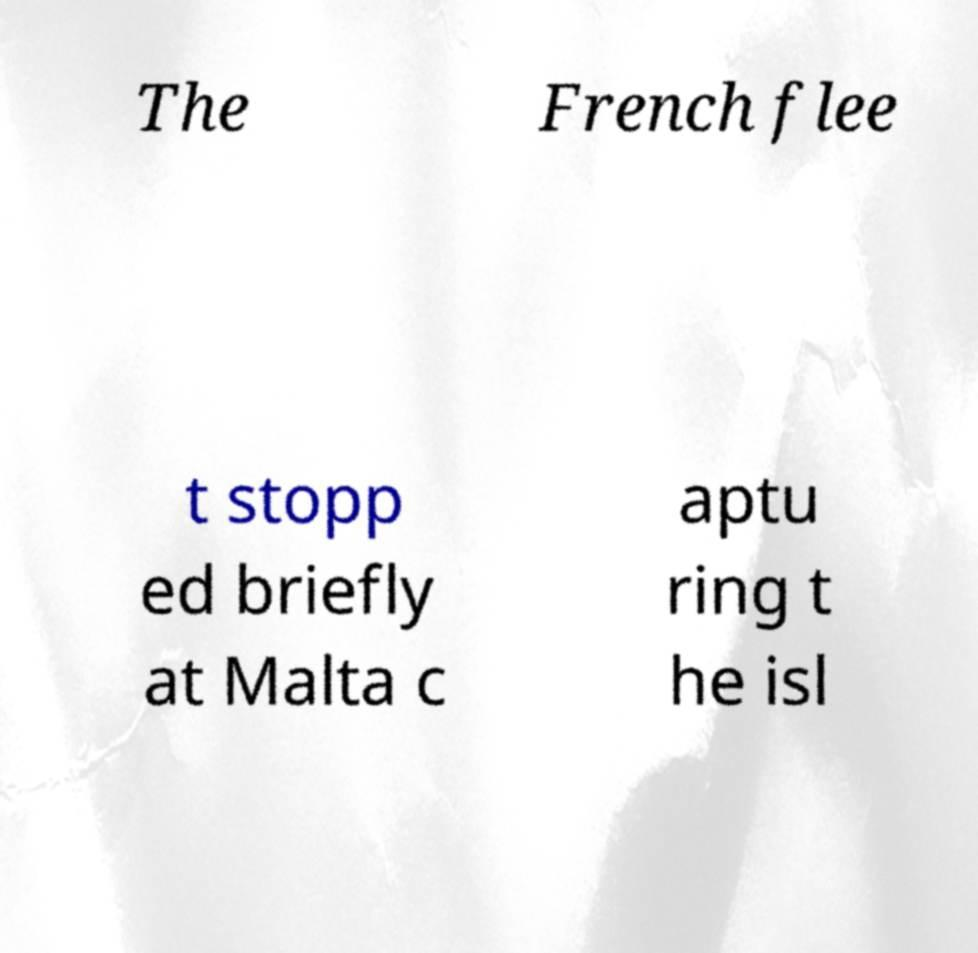Could you extract and type out the text from this image? The French flee t stopp ed briefly at Malta c aptu ring t he isl 